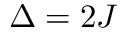<formula> <loc_0><loc_0><loc_500><loc_500>\Delta = 2 J</formula> 